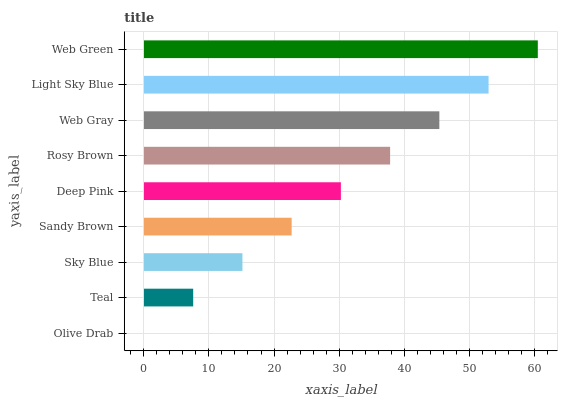Is Olive Drab the minimum?
Answer yes or no. Yes. Is Web Green the maximum?
Answer yes or no. Yes. Is Teal the minimum?
Answer yes or no. No. Is Teal the maximum?
Answer yes or no. No. Is Teal greater than Olive Drab?
Answer yes or no. Yes. Is Olive Drab less than Teal?
Answer yes or no. Yes. Is Olive Drab greater than Teal?
Answer yes or no. No. Is Teal less than Olive Drab?
Answer yes or no. No. Is Deep Pink the high median?
Answer yes or no. Yes. Is Deep Pink the low median?
Answer yes or no. Yes. Is Web Green the high median?
Answer yes or no. No. Is Light Sky Blue the low median?
Answer yes or no. No. 